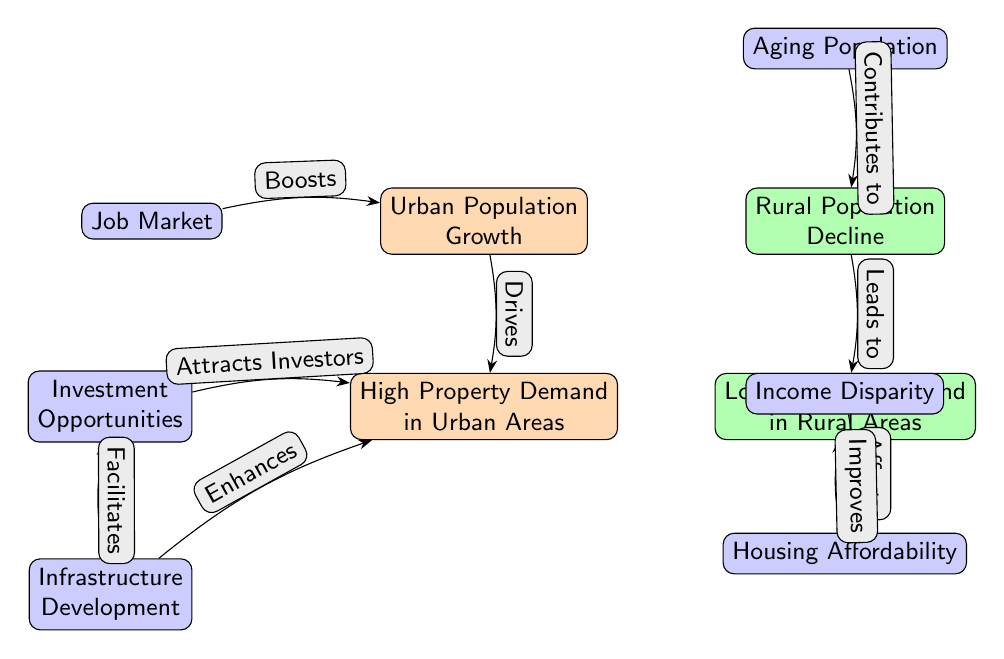What is the primary driver of high property demand in urban areas? The diagram indicates that "Urban Population Growth" drives "High Property Demand in Urban Areas." This relationship is shown through the arrow labeled "Drives" connecting these two nodes.
Answer: Urban Population Growth Which node is linked to "Low Property Demand in Rural Areas"? The "Low Property Demand in Rural Areas" node is directly connected to the "Rural Population Decline" node by an arrow labeled "Leads to." This is a direct correlation shown in the diagram.
Answer: Rural Population Decline How many common factors are presented in the diagram? The diagram shows three nodes labeled as common factors: "Income Disparity," "Housing Affordability," and "Investment Opportunities." Therefore, the total count of common factors is three.
Answer: 3 What does "Aging Population" contribute to? According to the diagram, the "Aging Population" node contributes to "Rural Population Decline," as denoted by the arrow labeled "Contributes to." This signifies a flow of influence from the aging demographic in rural areas.
Answer: Rural Population Decline What is the relationship between "Infrastructure Development" and "High Property Demand in Urban Areas"? The diagram shows that "Infrastructure Development" enhances "High Property Demand in Urban Areas" with the arrow labeled "Enhances." This indicates that improved infrastructure leads to greater demand for urban properties.
Answer: Enhances What impact does the "Job Market" have on "Urban Population Growth"? The "Job Market" boosts "Urban Population Growth," as shown by the arrow labeled "Boosts." This suggests that a strong job market contributes positively to population increases in urban settings.
Answer: Boosts Which node describes the consequences of income inequality on housing situations? The node "Housing Affordability" is affected by "Income Disparity," as represented by the arrow labeled "Affects." This indicates a correlation whereby income inequality impacts the affordability of housing.
Answer: Housing Affordability What does "Investment Opportunities" attract? The diagram illustrates that "Investment Opportunities" attracts "High Property Demand in Urban Areas," as indicated by the arrow labeled "Attracts Investors." This signifies a positive influx of investment due to demand in urban properties.
Answer: Attracts Investors How does "Infrastructure Development" relate to "Investment Opportunities"? "Infrastructure Development" facilitates "Investment Opportunities," as noted by the arrow labeled "Facilitates." This means that better infrastructure creates conditions favorable for investments in properties.
Answer: Facilitates 